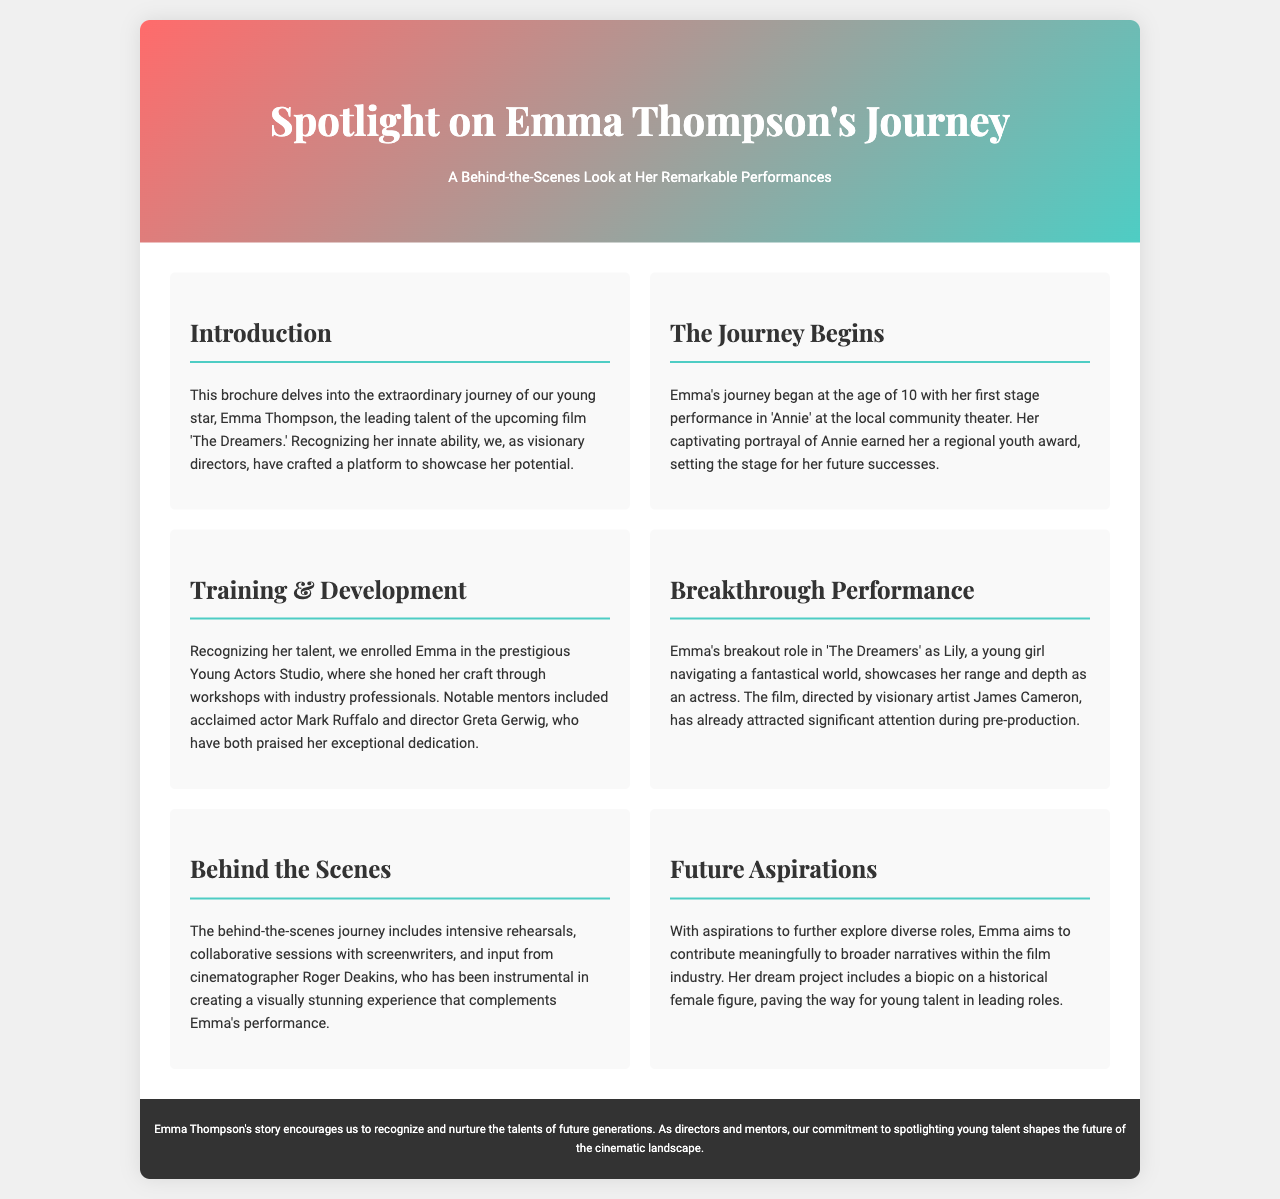What is the young star's name? The document introduces the young star as Emma Thompson, who plays the lead role in the upcoming film.
Answer: Emma Thompson At what age did Emma start performing? The brochure states that Emma's journey began at the age of 10 with her first stage performance.
Answer: 10 What award did Emma earn for her portrayal in 'Annie'? The document mentions that her captivating portrayal earned her a regional youth award.
Answer: Regional youth award Who praised Emma's dedication during her training? The text cites two notable mentors, Mark Ruffalo and Greta Gerwig, who have praised Emma's dedication.
Answer: Mark Ruffalo and Greta Gerwig What is the title of Emma's breakout performance? The section on Emma's breakthrough performance references the film 'The Dreamers' as her breakout role.
Answer: The Dreamers Who directed the film? The document notes that the film is directed by visionary artist James Cameron, making him the director.
Answer: James Cameron What is Emma's dream project? The brochure states that her dream project includes a biopic on a historical female figure.
Answer: Biopic on a historical female figure What is the purpose of this brochure? The text explains that the purpose of the brochure is to shed light on Emma Thompson's journey as a young star.
Answer: To shed light on Emma Thompson's journey 